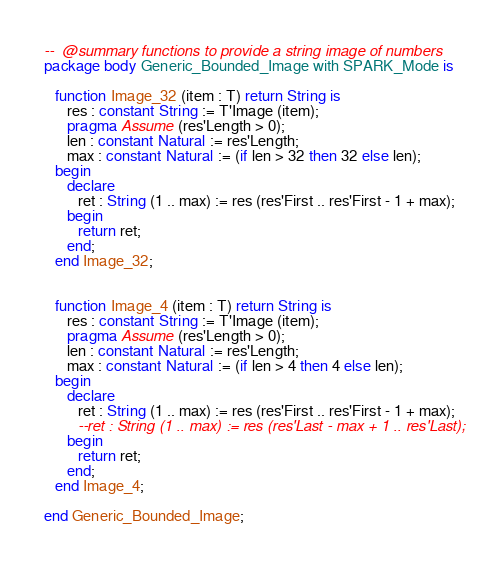Convert code to text. <code><loc_0><loc_0><loc_500><loc_500><_Ada_>--  @summary functions to provide a string image of numbers
package body Generic_Bounded_Image with SPARK_Mode is

   function Image_32 (item : T) return String is
      res : constant String := T'Image (item);
      pragma Assume (res'Length > 0);
      len : constant Natural := res'Length;
      max : constant Natural := (if len > 32 then 32 else len);
   begin
      declare
         ret : String (1 .. max) := res (res'First .. res'First - 1 + max);
      begin
         return ret;
      end;
   end Image_32;


   function Image_4 (item : T) return String is
      res : constant String := T'Image (item);
      pragma Assume (res'Length > 0);
      len : constant Natural := res'Length;
      max : constant Natural := (if len > 4 then 4 else len);
   begin
      declare
         ret : String (1 .. max) := res (res'First .. res'First - 1 + max);
         --ret : String (1 .. max) := res (res'Last - max + 1 .. res'Last);
      begin
         return ret;
      end;
   end Image_4;

end Generic_Bounded_Image;
</code> 